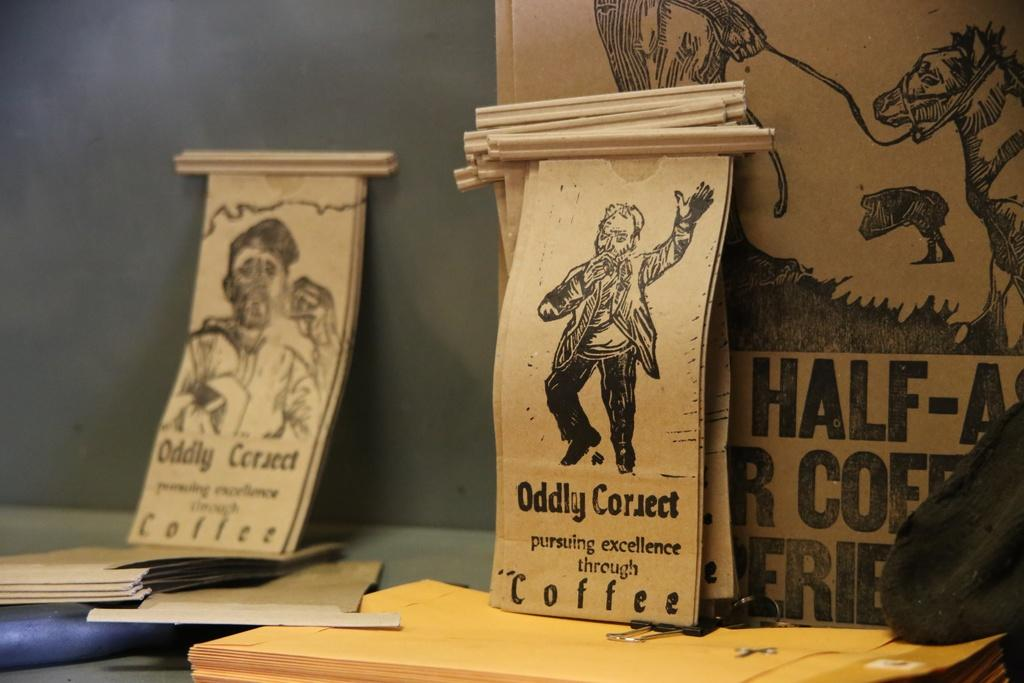<image>
Write a terse but informative summary of the picture. Oddly Correct pursuing excellence through coffee bags on table. 